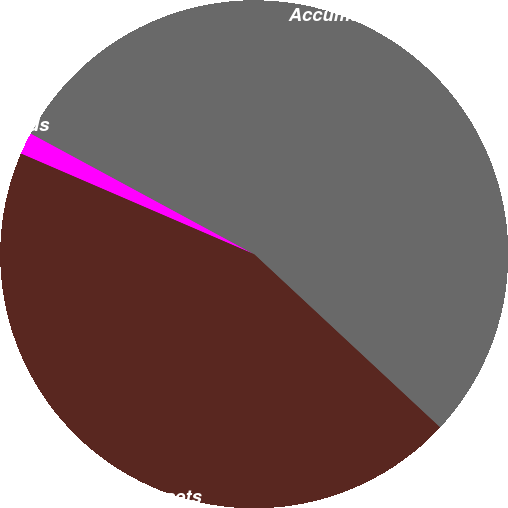<chart> <loc_0><loc_0><loc_500><loc_500><pie_chart><fcel>In thousands<fcel>Accumulated benefit obligation<fcel>Fair value of plan assets<nl><fcel>1.4%<fcel>54.05%<fcel>44.55%<nl></chart> 